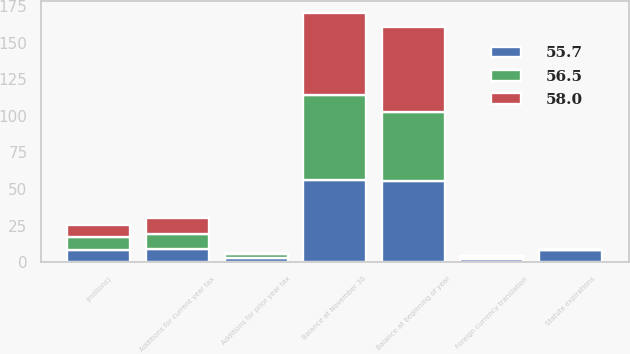Convert chart to OTSL. <chart><loc_0><loc_0><loc_500><loc_500><stacked_bar_chart><ecel><fcel>(millions)<fcel>Balance at beginning of year<fcel>Additions for current year tax<fcel>Additions for prior year tax<fcel>Statute expirations<fcel>Foreign currency translation<fcel>Balance at November 30<nl><fcel>55.7<fcel>8.5<fcel>55.7<fcel>8.9<fcel>3.2<fcel>8.1<fcel>2.3<fcel>56.5<nl><fcel>58<fcel>8.5<fcel>58<fcel>11.4<fcel>0.7<fcel>0.7<fcel>0.7<fcel>55.7<nl><fcel>56.5<fcel>8.5<fcel>46.7<fcel>10.3<fcel>2.2<fcel>0.1<fcel>1.1<fcel>58<nl></chart> 